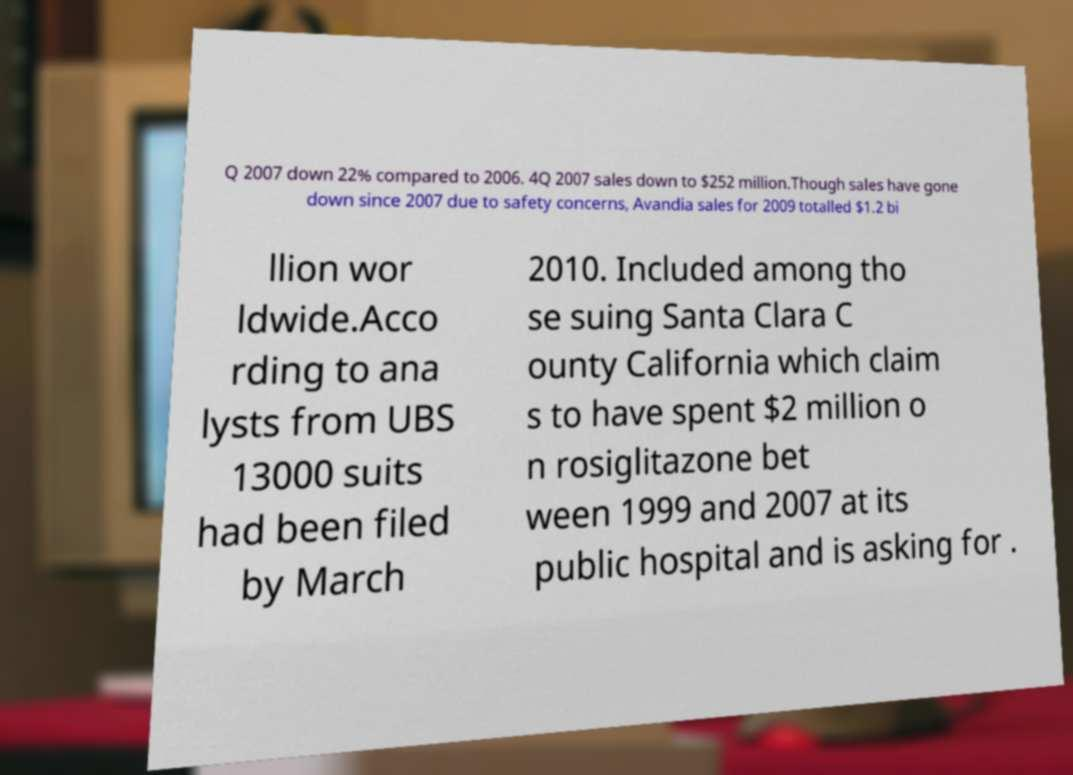Can you accurately transcribe the text from the provided image for me? Q 2007 down 22% compared to 2006. 4Q 2007 sales down to $252 million.Though sales have gone down since 2007 due to safety concerns, Avandia sales for 2009 totalled $1.2 bi llion wor ldwide.Acco rding to ana lysts from UBS 13000 suits had been filed by March 2010. Included among tho se suing Santa Clara C ounty California which claim s to have spent $2 million o n rosiglitazone bet ween 1999 and 2007 at its public hospital and is asking for . 